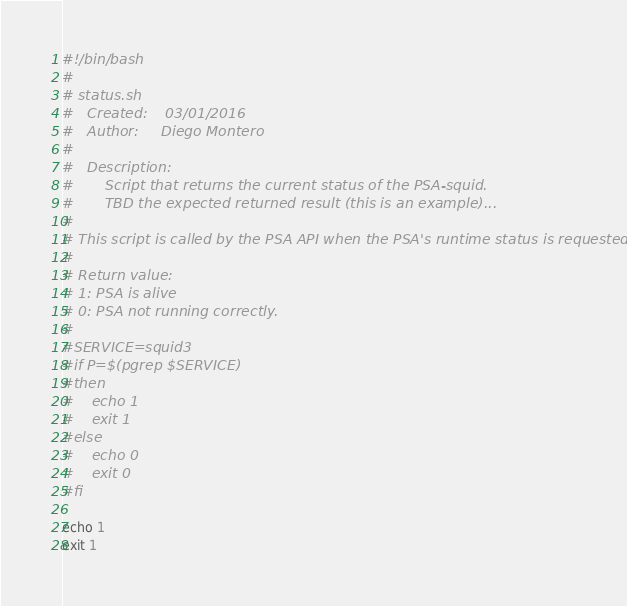Convert code to text. <code><loc_0><loc_0><loc_500><loc_500><_Bash_>#!/bin/bash
#
# status.sh
#   Created:    03/01/2016
#   Author:     Diego Montero
#   
#   Description:
#       Script that returns the current status of the PSA-squid.
#       TBD the expected returned result (this is an example)...
# 
# This script is called by the PSA API when the PSA's runtime status is requested.
# 
# Return value: 
# 1: PSA is alive
# 0: PSA not running correctly.
#
#SERVICE=squid3
#if P=$(pgrep $SERVICE)
#then
#    echo 1
#    exit 1
#else
#    echo 0
#    exit 0
#fi

echo 1
exit 1
</code> 